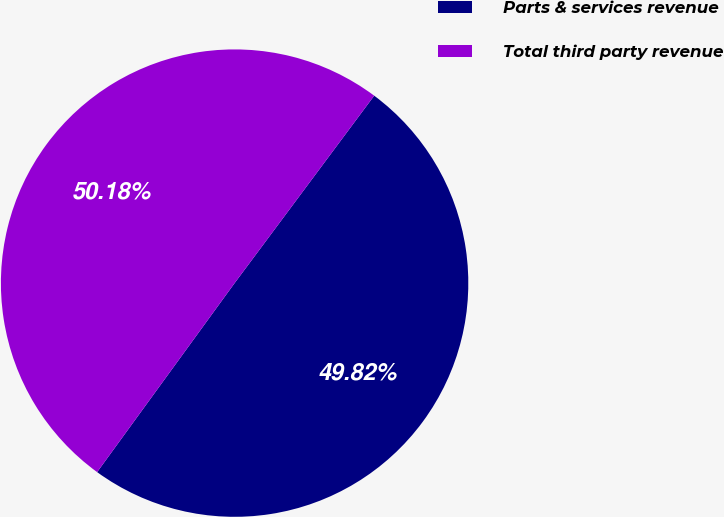<chart> <loc_0><loc_0><loc_500><loc_500><pie_chart><fcel>Parts & services revenue<fcel>Total third party revenue<nl><fcel>49.82%<fcel>50.18%<nl></chart> 